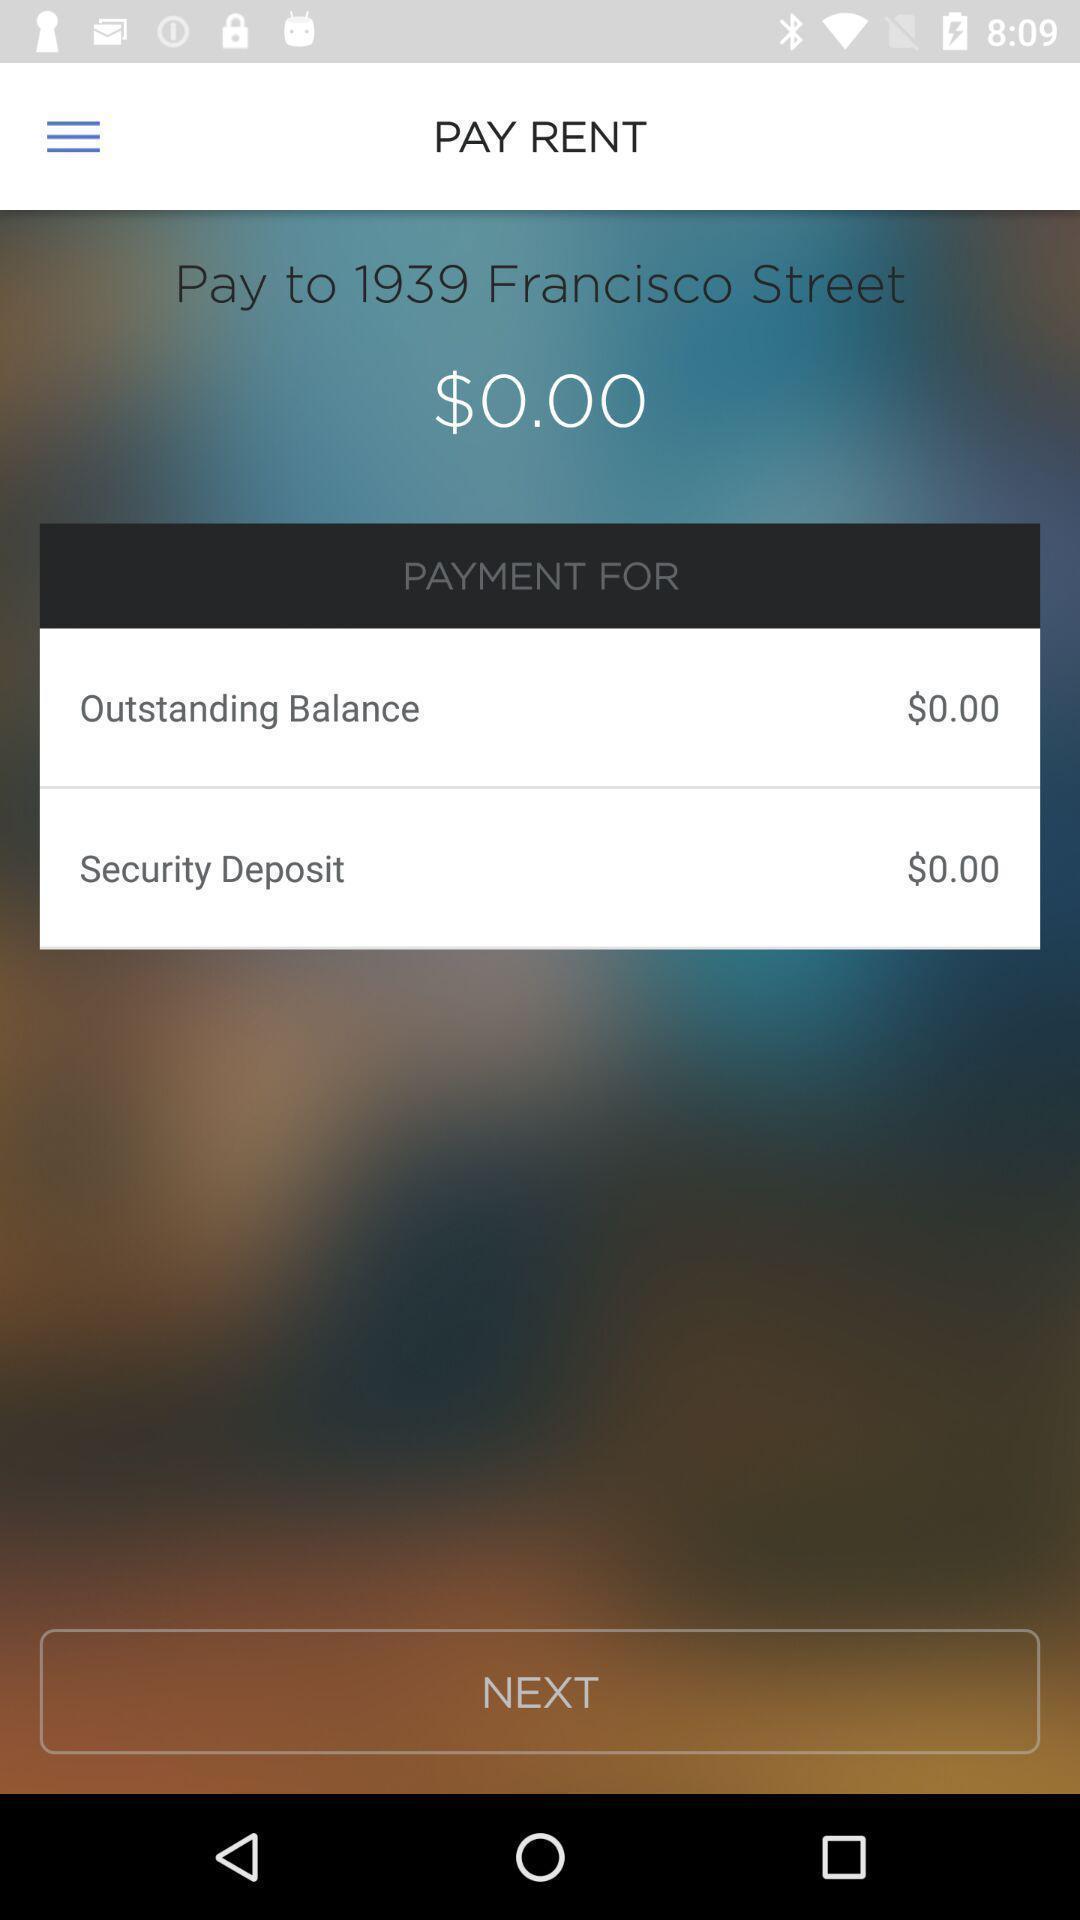Describe the key features of this screenshot. Screen displaying the payment page of a rent payment app. 